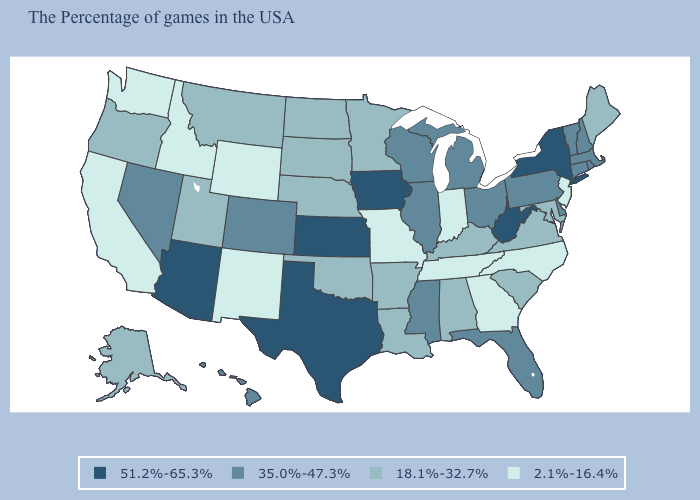Does the map have missing data?
Short answer required. No. Does New Jersey have the lowest value in the Northeast?
Give a very brief answer. Yes. How many symbols are there in the legend?
Write a very short answer. 4. Among the states that border California , does Oregon have the lowest value?
Keep it brief. Yes. Is the legend a continuous bar?
Give a very brief answer. No. Does Hawaii have the highest value in the West?
Write a very short answer. No. What is the value of Idaho?
Short answer required. 2.1%-16.4%. What is the value of Rhode Island?
Quick response, please. 35.0%-47.3%. Is the legend a continuous bar?
Concise answer only. No. What is the highest value in the Northeast ?
Quick response, please. 51.2%-65.3%. Does the map have missing data?
Concise answer only. No. Name the states that have a value in the range 18.1%-32.7%?
Keep it brief. Maine, Maryland, Virginia, South Carolina, Kentucky, Alabama, Louisiana, Arkansas, Minnesota, Nebraska, Oklahoma, South Dakota, North Dakota, Utah, Montana, Oregon, Alaska. Which states have the lowest value in the USA?
Write a very short answer. New Jersey, North Carolina, Georgia, Indiana, Tennessee, Missouri, Wyoming, New Mexico, Idaho, California, Washington. Does Maryland have the highest value in the South?
Be succinct. No. What is the value of Utah?
Give a very brief answer. 18.1%-32.7%. 